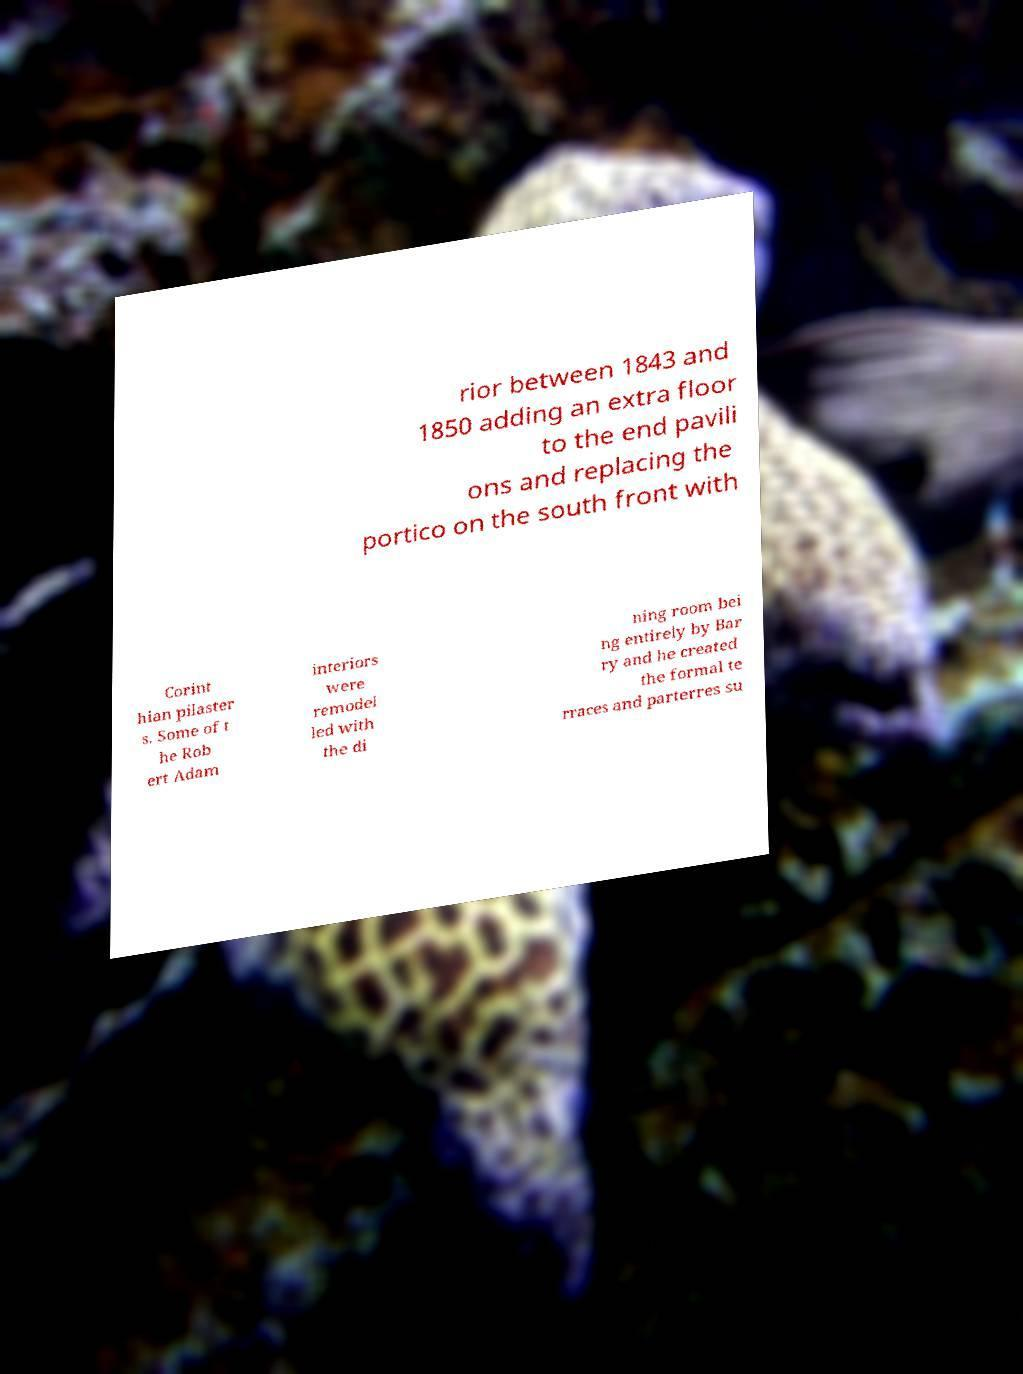I need the written content from this picture converted into text. Can you do that? rior between 1843 and 1850 adding an extra floor to the end pavili ons and replacing the portico on the south front with Corint hian pilaster s. Some of t he Rob ert Adam interiors were remodel led with the di ning room bei ng entirely by Bar ry and he created the formal te rraces and parterres su 